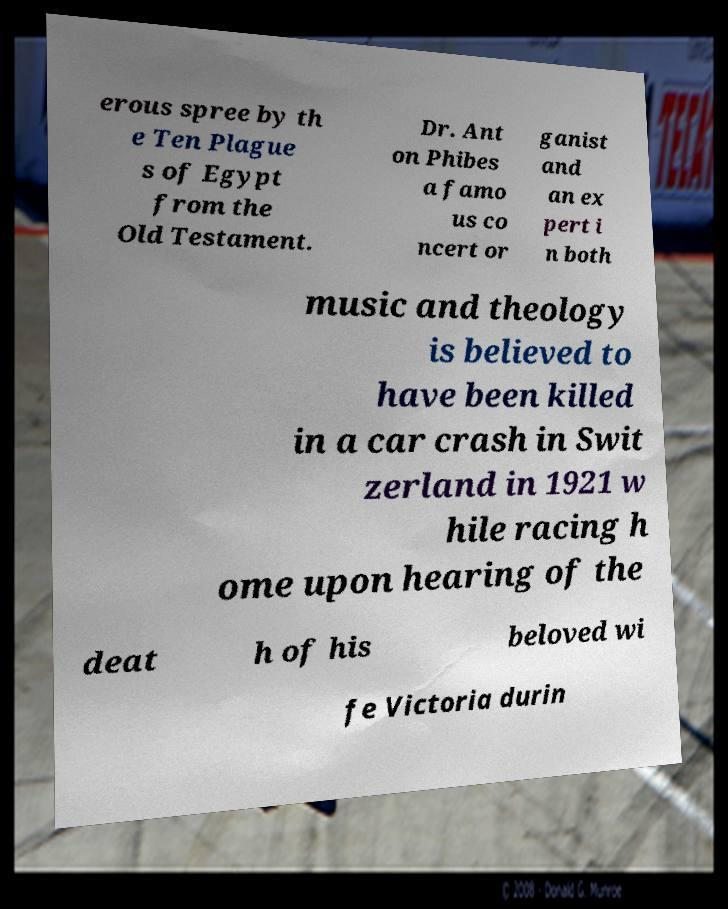For documentation purposes, I need the text within this image transcribed. Could you provide that? erous spree by th e Ten Plague s of Egypt from the Old Testament. Dr. Ant on Phibes a famo us co ncert or ganist and an ex pert i n both music and theology is believed to have been killed in a car crash in Swit zerland in 1921 w hile racing h ome upon hearing of the deat h of his beloved wi fe Victoria durin 